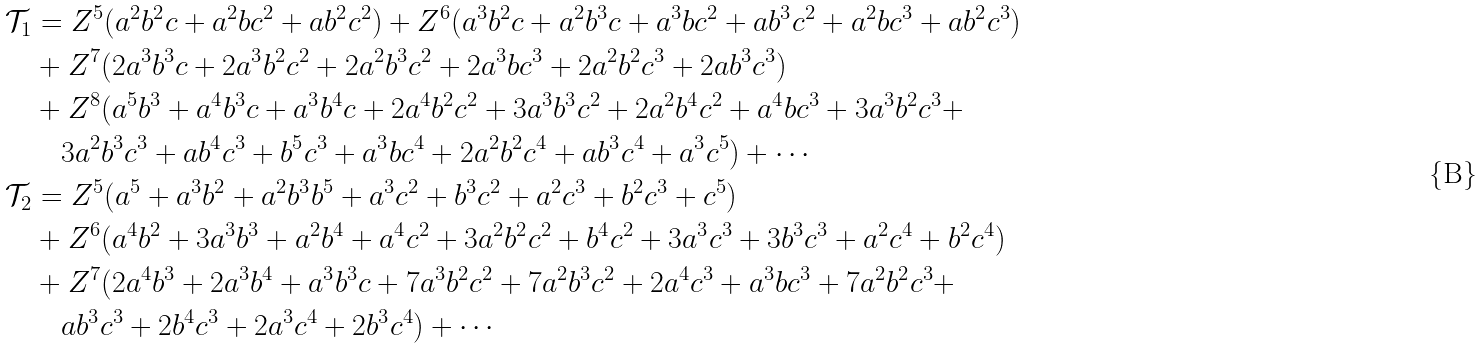<formula> <loc_0><loc_0><loc_500><loc_500>\mathcal { T } _ { 1 } & = Z ^ { 5 } ( a ^ { 2 } b ^ { 2 } c + a ^ { 2 } b c ^ { 2 } + a b ^ { 2 } c ^ { 2 } ) + Z ^ { 6 } ( a ^ { 3 } b ^ { 2 } c + a ^ { 2 } b ^ { 3 } c + a ^ { 3 } b c ^ { 2 } + a b ^ { 3 } c ^ { 2 } + a ^ { 2 } b c ^ { 3 } + a b ^ { 2 } c ^ { 3 } ) \\ & + Z ^ { 7 } ( 2 a ^ { 3 } b ^ { 3 } c + 2 a ^ { 3 } b ^ { 2 } c ^ { 2 } + 2 a ^ { 2 } b ^ { 3 } c ^ { 2 } + 2 a ^ { 3 } b c ^ { 3 } + 2 a ^ { 2 } b ^ { 2 } c ^ { 3 } + 2 a b ^ { 3 } c ^ { 3 } ) \\ & + Z ^ { 8 } ( a ^ { 5 } b ^ { 3 } + a ^ { 4 } b ^ { 3 } c + a ^ { 3 } b ^ { 4 } c + 2 a ^ { 4 } b ^ { 2 } c ^ { 2 } + 3 a ^ { 3 } b ^ { 3 } c ^ { 2 } + 2 a ^ { 2 } b ^ { 4 } c ^ { 2 } + a ^ { 4 } b c ^ { 3 } + 3 a ^ { 3 } b ^ { 2 } c ^ { 3 } + \\ & \quad 3 a ^ { 2 } b ^ { 3 } c ^ { 3 } + a b ^ { 4 } c ^ { 3 } + b ^ { 5 } c ^ { 3 } + a ^ { 3 } b c ^ { 4 } + 2 a ^ { 2 } b ^ { 2 } c ^ { 4 } + a b ^ { 3 } c ^ { 4 } + a ^ { 3 } c ^ { 5 } ) + \cdots \\ \mathcal { T } _ { 2 } & = Z ^ { 5 } ( a ^ { 5 } + a ^ { 3 } b ^ { 2 } + a ^ { 2 } b ^ { 3 } b ^ { 5 } + a ^ { 3 } c ^ { 2 } + b ^ { 3 } c ^ { 2 } + a ^ { 2 } c ^ { 3 } + b ^ { 2 } c ^ { 3 } + c ^ { 5 } ) \\ & + Z ^ { 6 } ( a ^ { 4 } b ^ { 2 } + 3 a ^ { 3 } b ^ { 3 } + a ^ { 2 } b ^ { 4 } + a ^ { 4 } c ^ { 2 } + 3 a ^ { 2 } b ^ { 2 } c ^ { 2 } + b ^ { 4 } c ^ { 2 } + 3 a ^ { 3 } c ^ { 3 } + 3 b ^ { 3 } c ^ { 3 } + a ^ { 2 } c ^ { 4 } + b ^ { 2 } c ^ { 4 } ) \\ & + Z ^ { 7 } ( 2 a ^ { 4 } b ^ { 3 } + 2 a ^ { 3 } b ^ { 4 } + a ^ { 3 } b ^ { 3 } c + 7 a ^ { 3 } b ^ { 2 } c ^ { 2 } + 7 a ^ { 2 } b ^ { 3 } c ^ { 2 } + 2 a ^ { 4 } c ^ { 3 } + a ^ { 3 } b c ^ { 3 } + 7 a ^ { 2 } b ^ { 2 } c ^ { 3 } + \\ & \quad a b ^ { 3 } c ^ { 3 } + 2 b ^ { 4 } c ^ { 3 } + 2 a ^ { 3 } c ^ { 4 } + 2 b ^ { 3 } c ^ { 4 } ) + \cdots</formula> 